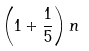Convert formula to latex. <formula><loc_0><loc_0><loc_500><loc_500>\left ( 1 + { \frac { 1 } { 5 } } \right ) n</formula> 